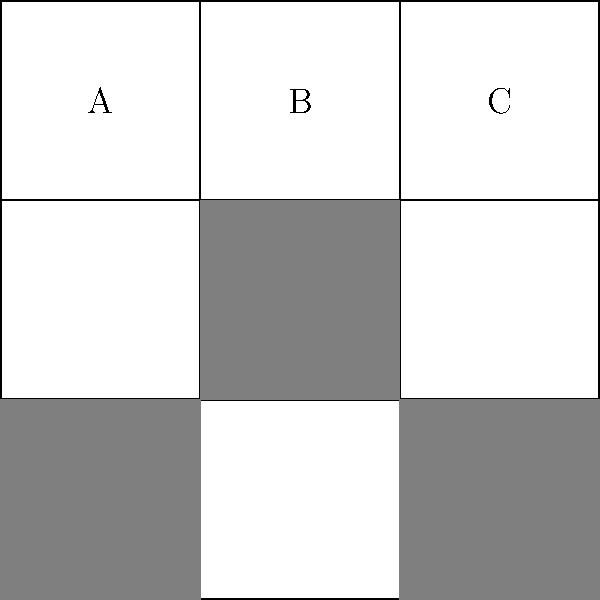Given the visual cryptography pattern above, which represents a coded message using a 3x3 grid where shaded cells indicate '1' and unshaded cells indicate '0', what is the binary representation of the message? To decipher the coded message using visual cryptography techniques, follow these steps:

1. Understand the encoding:
   - Shaded cells represent '1'
   - Unshaded cells represent '0'

2. Read the grid from left to right, top to bottom:
   Row 1: 0 0 0
   Row 2: 1 0 1
   Row 3: 1 1 0

3. Combine the binary digits:
   001011010

4. Group the binary digits into sets of three:
   001 011 010

5. Convert each group to its decimal equivalent:
   001 = 1
   011 = 3
   010 = 2

6. Map the decimal numbers to letters (A=1, B=2, C=3, etc.):
   1 = A
   3 = C
   2 = B

Therefore, the decoded message is "ACB".
Answer: ACB 